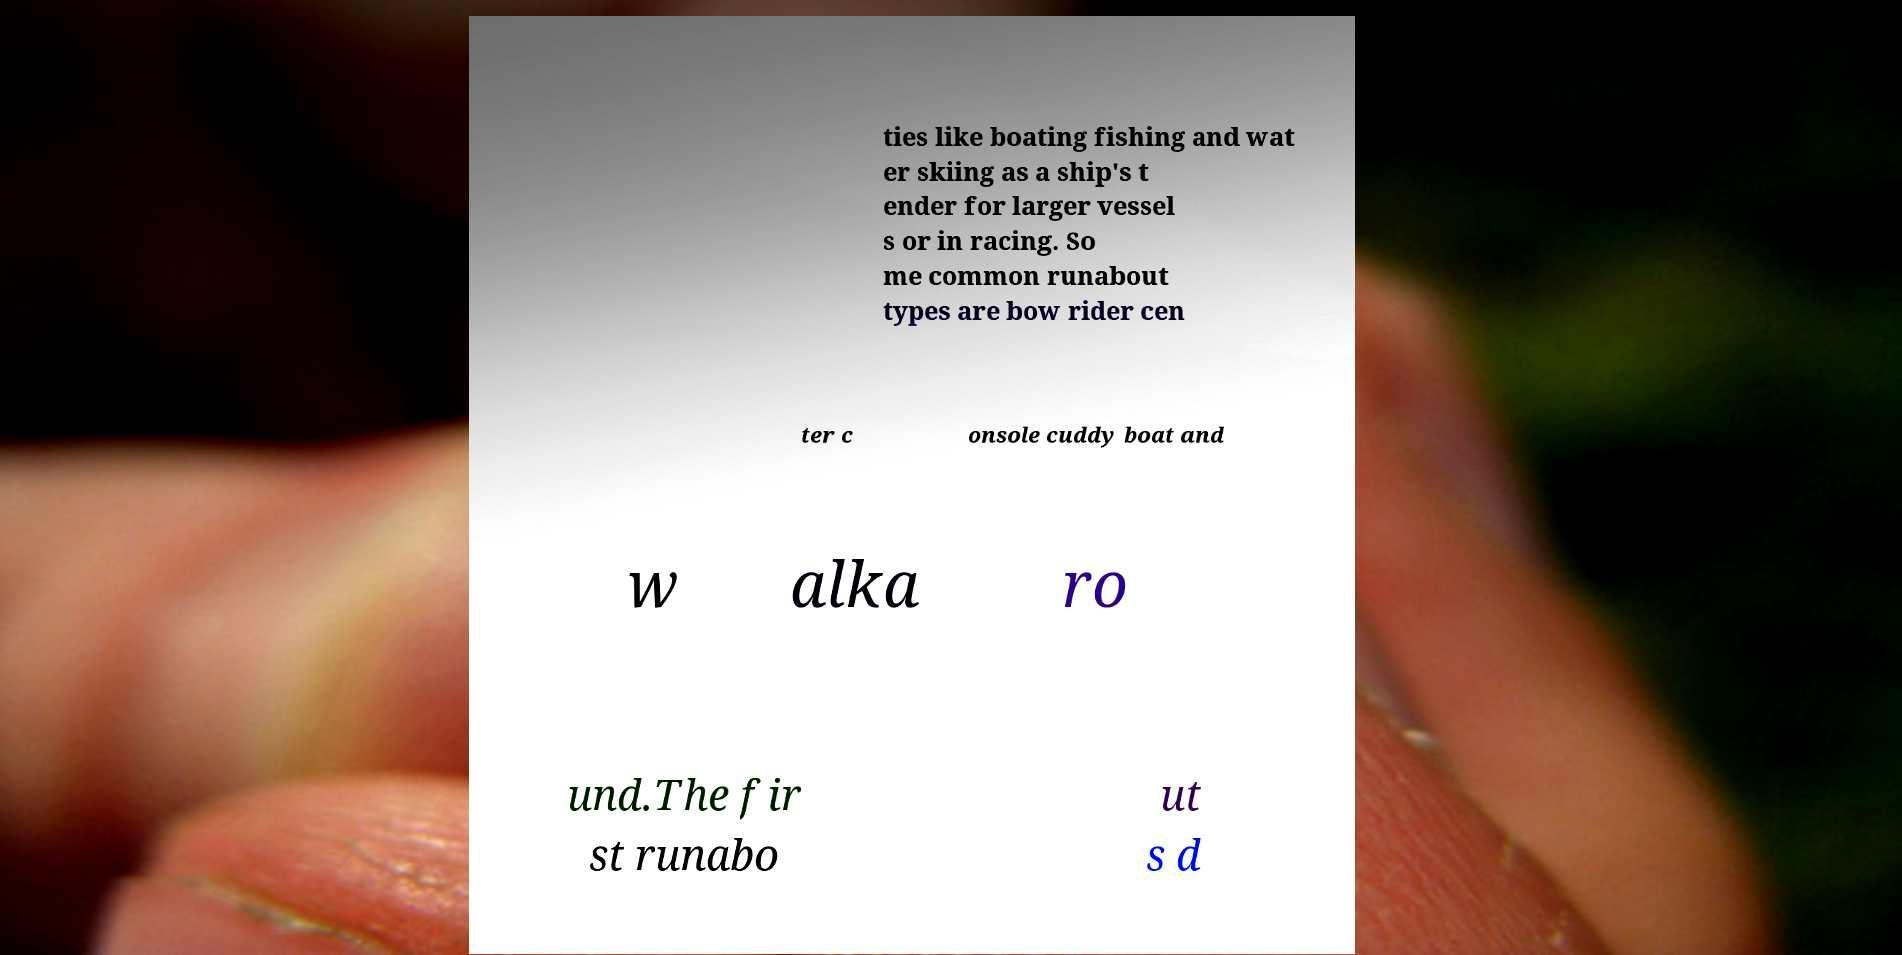Please read and relay the text visible in this image. What does it say? ties like boating fishing and wat er skiing as a ship's t ender for larger vessel s or in racing. So me common runabout types are bow rider cen ter c onsole cuddy boat and w alka ro und.The fir st runabo ut s d 